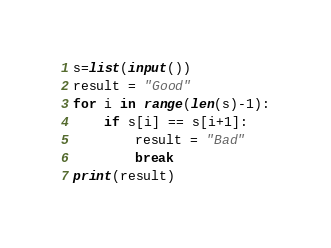<code> <loc_0><loc_0><loc_500><loc_500><_Python_>s=list(input())
result = "Good"
for i in range(len(s)-1):
    if s[i] == s[i+1]:
        result = "Bad"
        break
print(result)</code> 